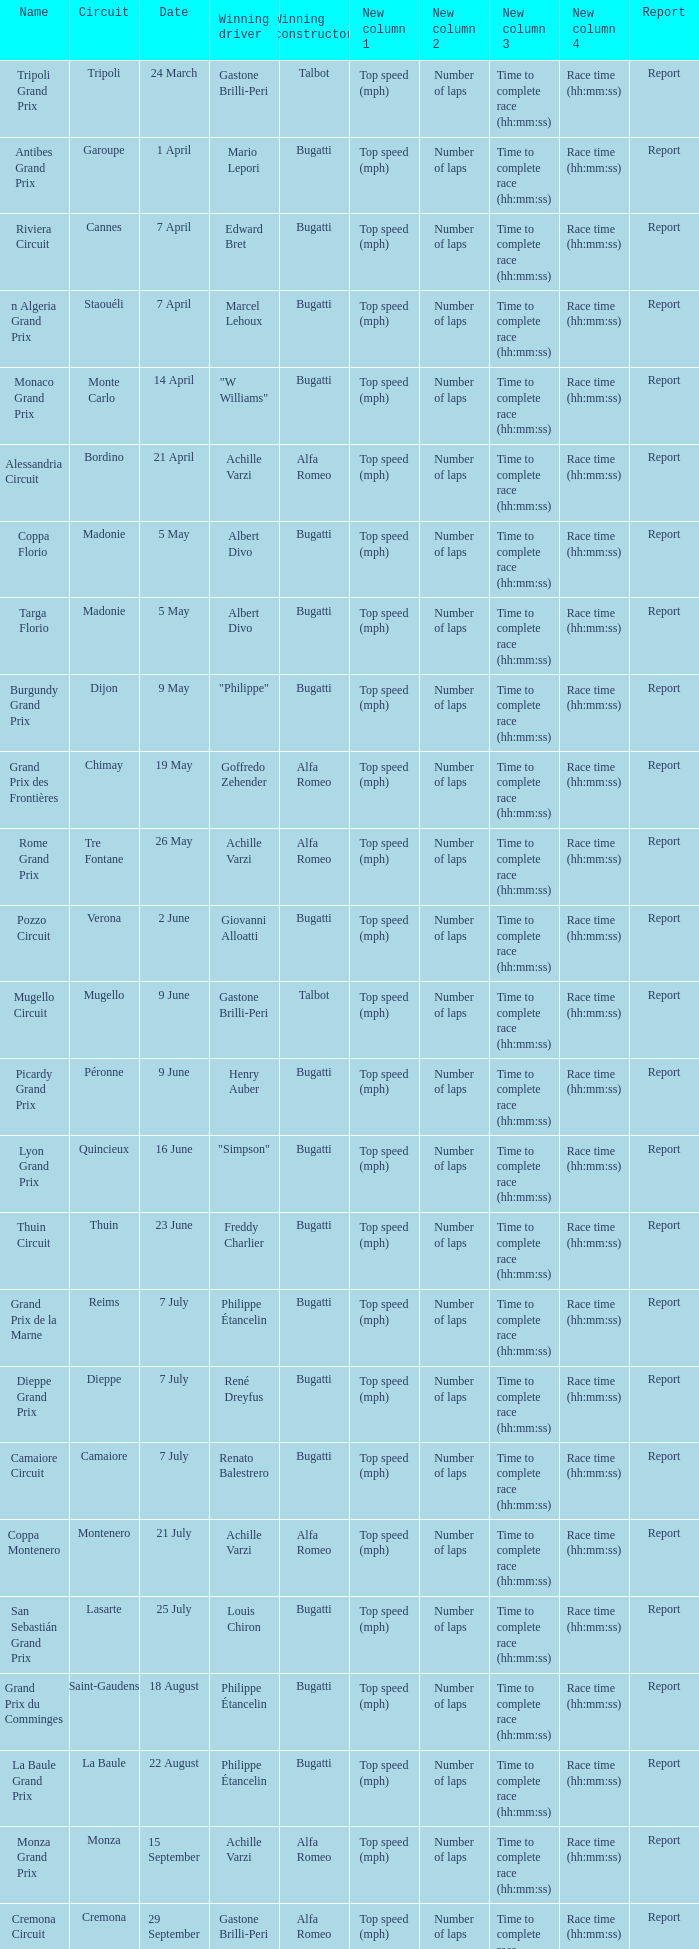What Circuit has a Winning constructor of bugatti, and a Winning driver of edward bret? Cannes. 